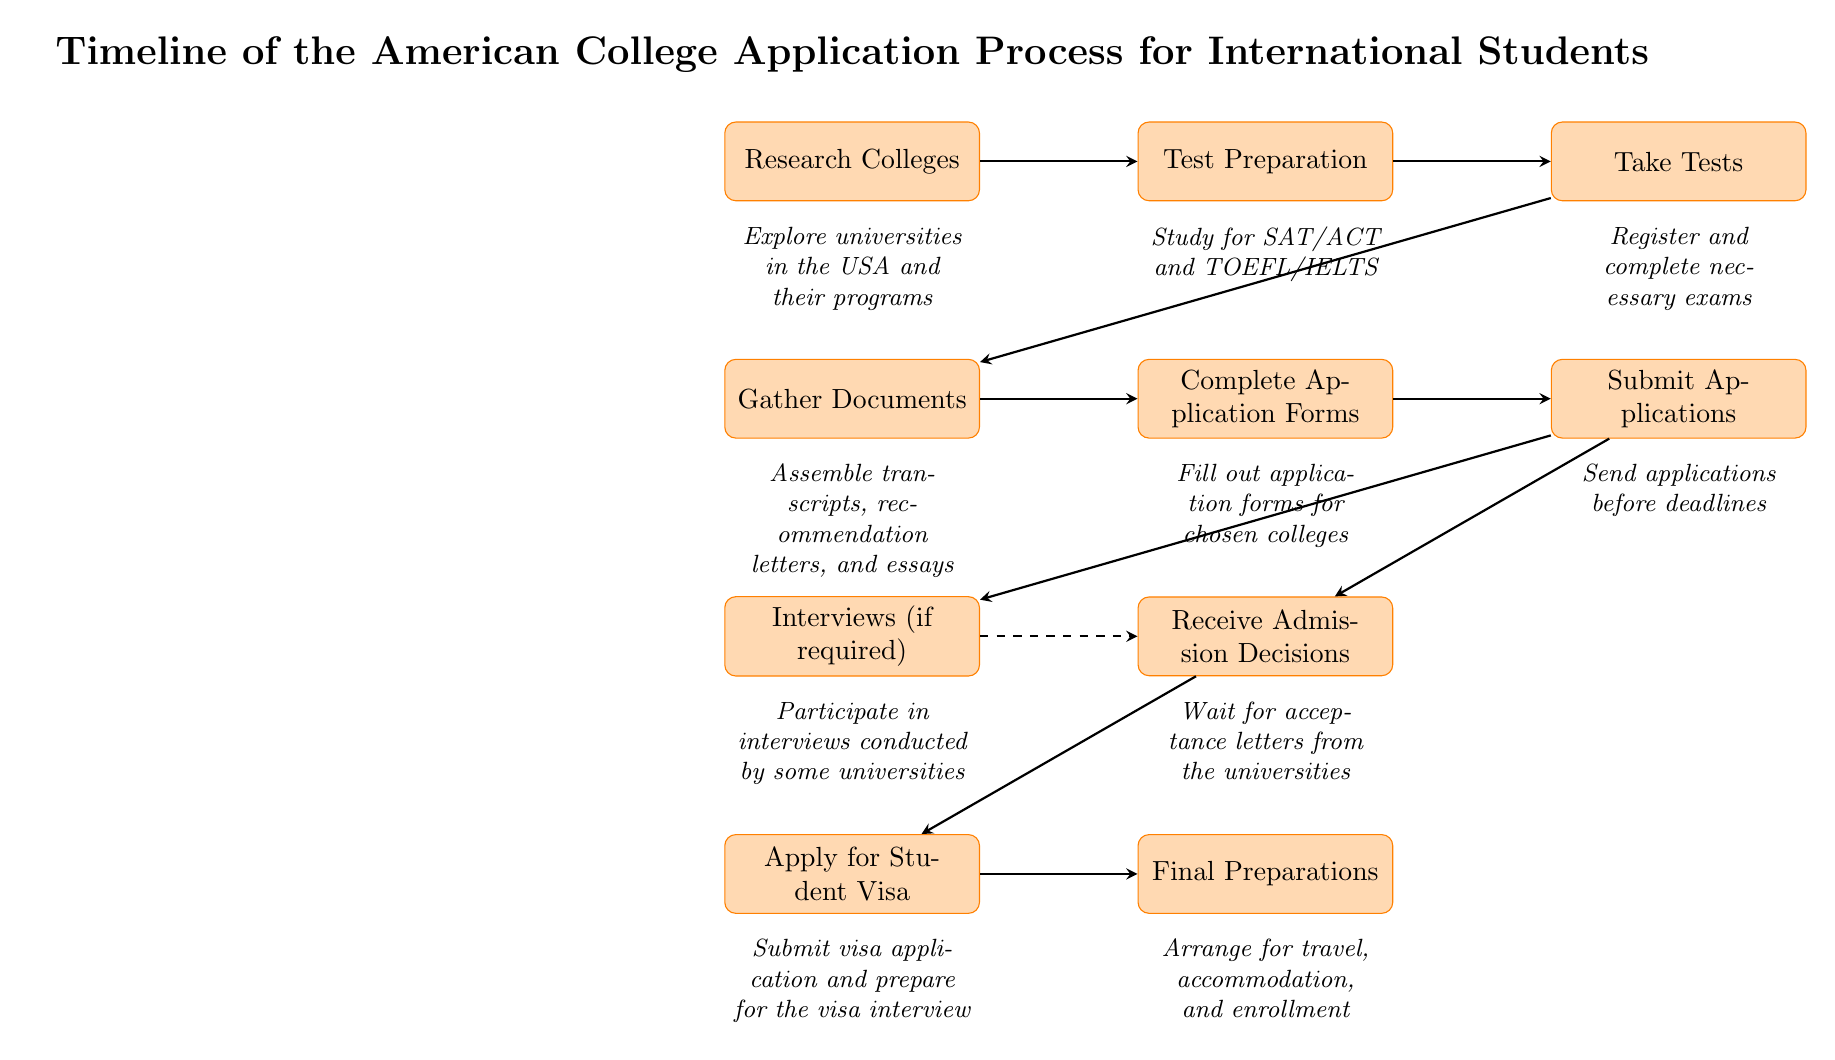What is the first step in the application process? The first step as depicted in the diagram is "Research Colleges." This is shown as the topmost node in the sequence, indicating it is the starting point.
Answer: Research Colleges How many main steps are there in the application process? By counting the process nodes in the diagram, there are a total of 10 main steps represented, which include various stages from research to final preparations.
Answer: 10 What follows after "Take Tests"? The next step after "Take Tests" is "Gather Documents." In the diagram, there is a direct arrow leading from "Take Tests" to "Gather Documents," indicating this sequence.
Answer: Gather Documents Is there an optional step in the application process? Yes, "Interviews (if required)" is indicated as an optional step, which is shown as a separate node branching from "Submit Applications." It is indicated that not all universities require them.
Answer: Interviews (if required) What do students do after receiving admission decisions? After receiving admission decisions, the next step is "Apply for Student Visa." This is reflected in the diagram with an arrow leading from "Receive Admission Decisions" to "Apply for Student Visa."
Answer: Apply for Student Visa Is there a direct connection between submitting applications and interviews? Yes, there is a direct connection indicated by the dashed arrow from "Interviews (if required)" to "Receive Admission Decisions," meaning that they are related but do not have a direct sequential dependency.
Answer: Yes What do students do before making final preparations? Students need to "Apply for Student Visa" before making final preparations. The flow in the diagram shows that "Apply for Student Visa" precedes "Final Preparations."
Answer: Apply for Student Visa How are the steps organized in this diagram? The steps are organized in a linear fashion, with arrows indicating the sequence of actions. This structure allows for easy understanding of the flow from one stage to the next in the college application process.
Answer: Linear fashion 